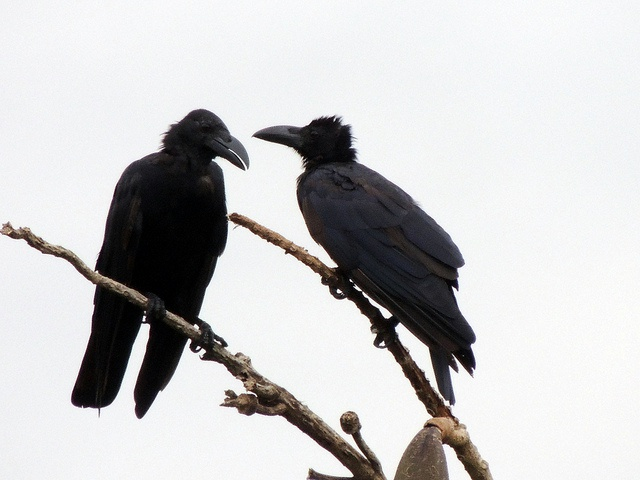Describe the objects in this image and their specific colors. I can see bird in white, black, gray, and darkgray tones and bird in white, black, and gray tones in this image. 